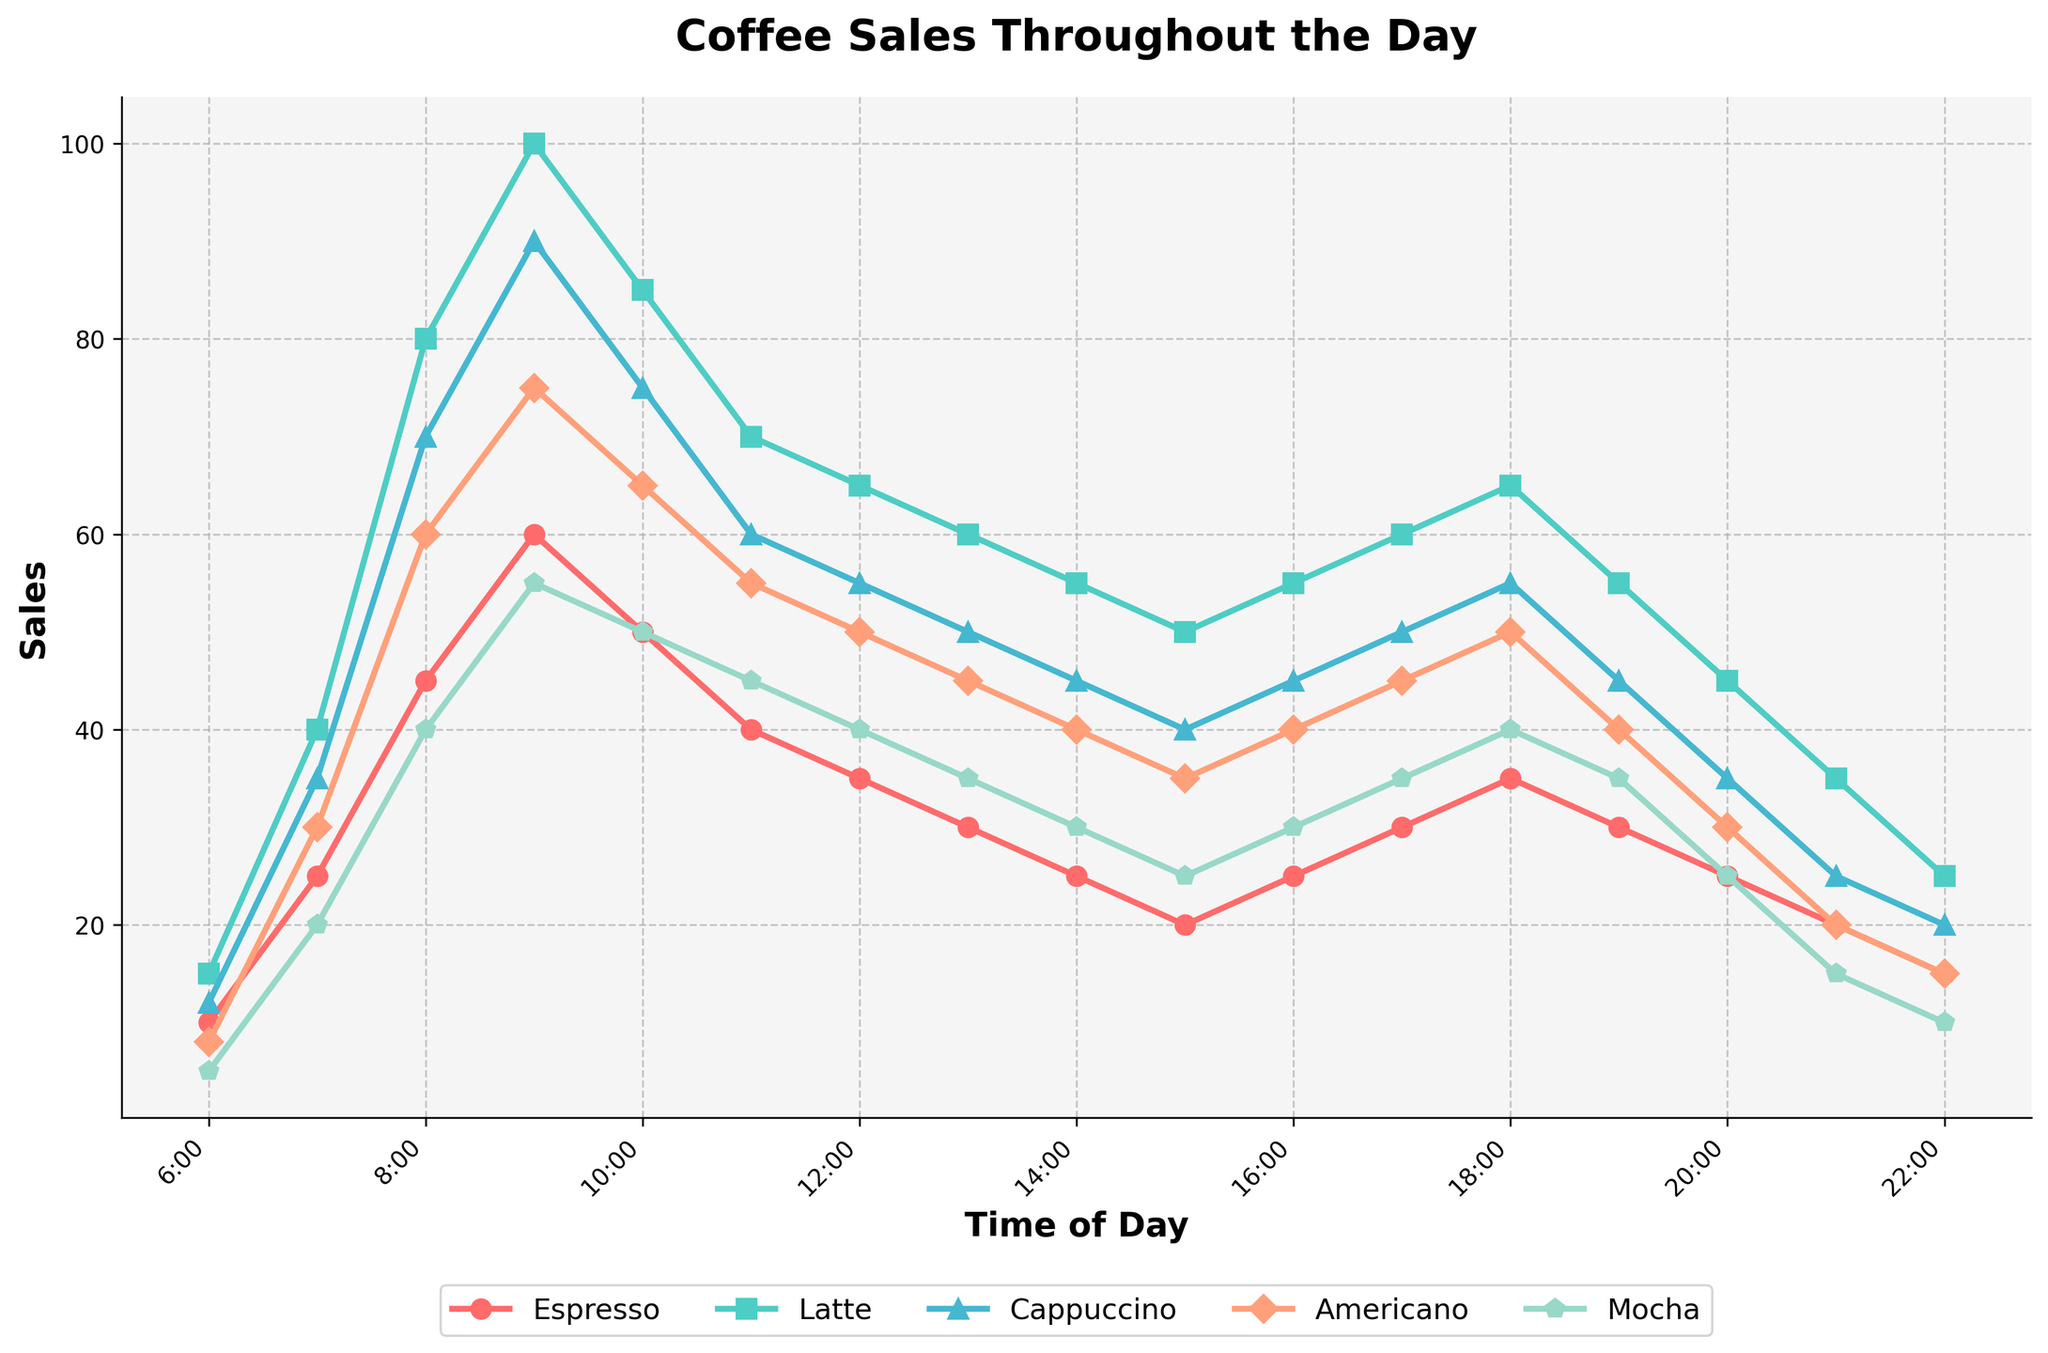What time do Latte sales peak? Looking at the chart, the highest point on the Latte line is at 9:00.
Answer: 9:00 Which coffee type has the lowest sales at 8:00? By comparing the heights of all lines at 8:00, Mocha has the lowest sales.
Answer: Mocha How much do Espresso sales decrease from 9:00 to 10:00? Espresso sales at 9:00 are 60, and at 10:00 they are 50. The decrease is 60 - 50 = 10.
Answer: 10 Which two-hour interval shows the largest increase in Cappuccino sales? Comparing hour-by-hour increases, the largest increase is from 7:00 to 9:00, where sales go from 35 to 90, an increase of 55.
Answer: 7:00 to 9:00 What's the total sales of Americano and Mocha at 6:00? Americano sales at 6:00 are 8, and Mocha sales are 5. The total is 8 + 5 = 13.
Answer: 13 At what time do Espresso and Americano sales intersect? The lines for Espresso and Americano intersect at 16:00, where both are at 25 sales.
Answer: 16:00 During which time period is the difference between Latte and Espresso sales highest? The largest gap between Latte and Espresso sales is at 9:00, where Latte has 100 sales and Espresso has 60, a difference of 40.
Answer: 9:00 How many coffee types have higher sales at 18:00 compared to 22:00? Comparing the bars at 18:00 and 22:00 for each coffee, Espresso, Latte, Cappuccino, Americano, and Mocha all have higher sales at 18:00.
Answer: 5 What is the overall trend for Cappuccino sales throughout the day? Cappuccino sales rise sharply until 9:00, then generally decline with minor fluctuations throughout the rest of the day.
Answer: Rises then declines What is the average sales of Mocha between 7:00 and 9:00? The sales at 7:00, 8:00, and 9:00 are 20, 40, and 55 respectively. The average is (20 + 40 + 55) / 3 = 38.33 (approximately).
Answer: 38.33 